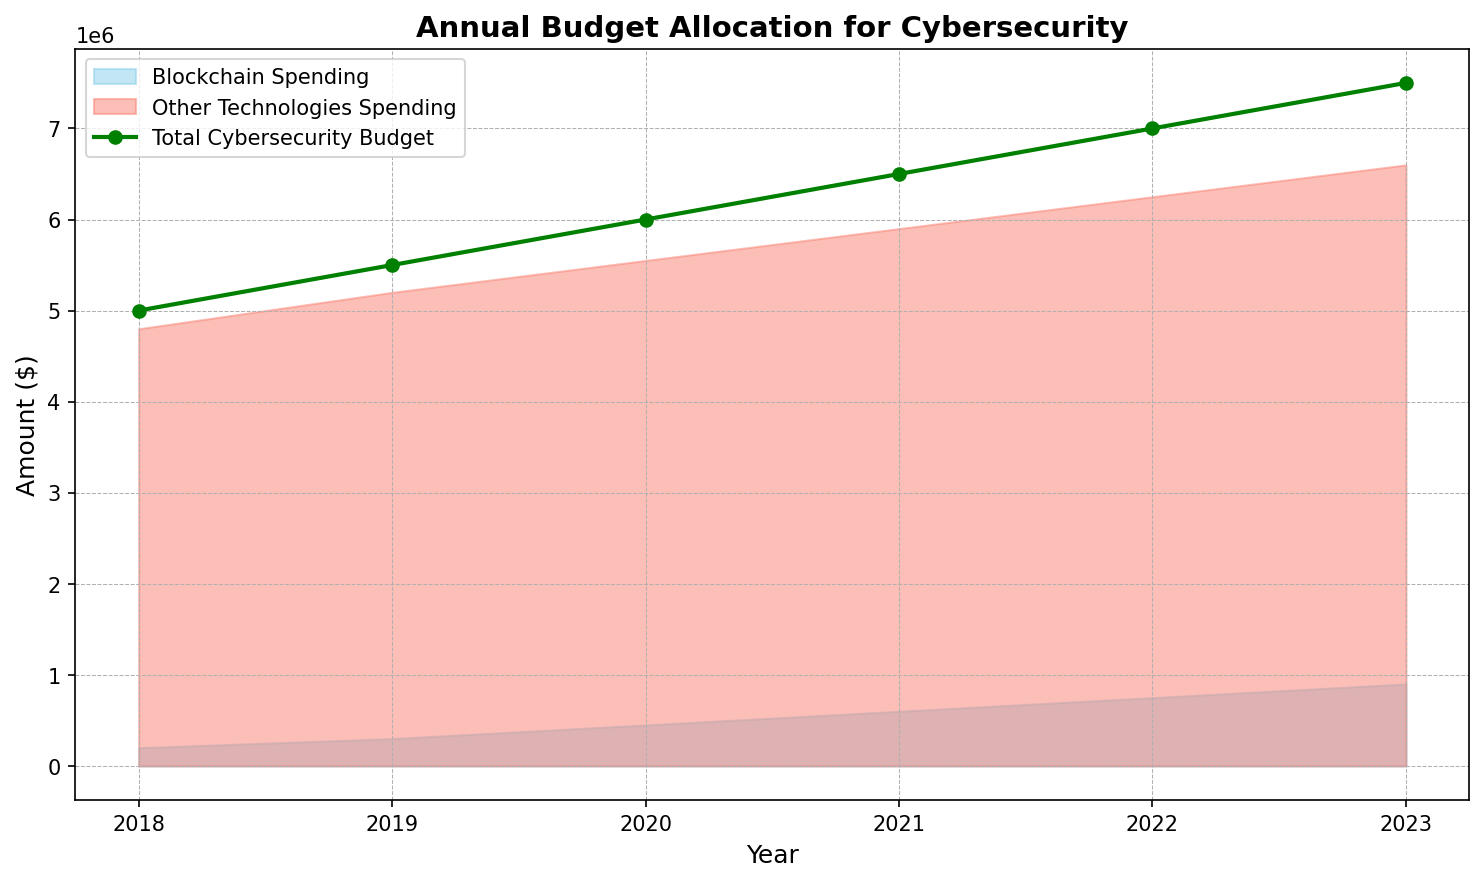How has the total cybersecurity budget changed from 2018 to 2023? The total cybersecurity budget in 2018 was $5,000,000, and it increased each year. By 2023, it reached $7,500,000, showing an overall increase of $2,500,000.
Answer: It has increased by $2,500,000 Which technology saw a greater absolute increase in spending from 2018 to 2023, blockchain or other technologies? Blockchain spending increased from $200,000 in 2018 to $900,000 in 2023, an increase of $700,000. Other technologies spending increased from $4,800,000 in 2018 to $6,600,000 in 2023, an increase of $1,800,000.
Answer: Other technologies saw a greater increase in absolute spending In which year did blockchain spending first exceed $500,000? Blockchain spending first exceeded $500,000 in 2021, reaching $600,000.
Answer: 2021 Compare the percentage of the total cybersecurity budget allocated to blockchain in 2020 and 2023. In 2020, the total budget was $6,000,000, and blockchain spending was $450,000, which is 7.5%. In 2023, the total budget was $7,500,000, and blockchain spending was $900,000, which is 12%.
Answer: 7.5% in 2020 and 12% in 2023 Which had a greater increase in allocation percentage from 2018 to 2023: blockchain or other technologies? In 2018, blockchain spending was 4% of the total budget, and in 2023 it was 12%, increasing by 8%. Other technologies spending was 96% in 2018 and dropped to 88% in 2023, decreasing by 8%. Hence, blockchain saw a greater increase in allocation percentage.
Answer: Blockchain by 8% Is there a particular year where the spending on other technologies did not follow the overall increasing trend in total cybersecurity budget? Each year from 2018 to 2023, the spending on other technologies consistently increased in line with the overall cybersecurity budget.
Answer: No How much more was spent on other technologies compared to blockchain in 2022? In 2022, spending on other technologies was $6,250,000, and spending on blockchain was $750,000. The difference is $6,250,000 - $750,000, which equals $5,500,000.
Answer: $5,500,000 What is the average annual increase in blockchain spending between 2018 and 2023? The increase in blockchain spending from 2018 to 2023 is $900,000 - $200,000 = $700,000. Dividing this by the 5-year interval gives an average annual increase of $700,000 / 5 = $140,000.
Answer: $140,000 How does the height of the area representing blockchain spending in 2023 compare to other years? The area representing blockchain spending in 2023 is the highest compared to other years, indicating the maximum allocation to blockchain within the given timeframe.
Answer: Highest 